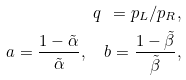<formula> <loc_0><loc_0><loc_500><loc_500>q \ = p _ { L } / p _ { R } , \\ a = \frac { 1 - \tilde { \alpha } } { \tilde { \alpha } } , \quad b = \frac { 1 - \tilde { \beta } } { \tilde { \beta } } ,</formula> 